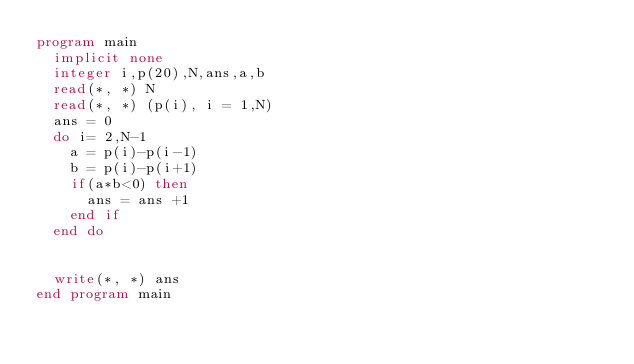Convert code to text. <code><loc_0><loc_0><loc_500><loc_500><_FORTRAN_>program main
  implicit none
  integer i,p(20),N,ans,a,b
  read(*, *) N
  read(*, *) (p(i), i = 1,N)
  ans = 0
  do i= 2,N-1
    a = p(i)-p(i-1)
    b = p(i)-p(i+1)
    if(a*b<0) then
      ans = ans +1
    end if
  end do


  write(*, *) ans
end program main
</code> 